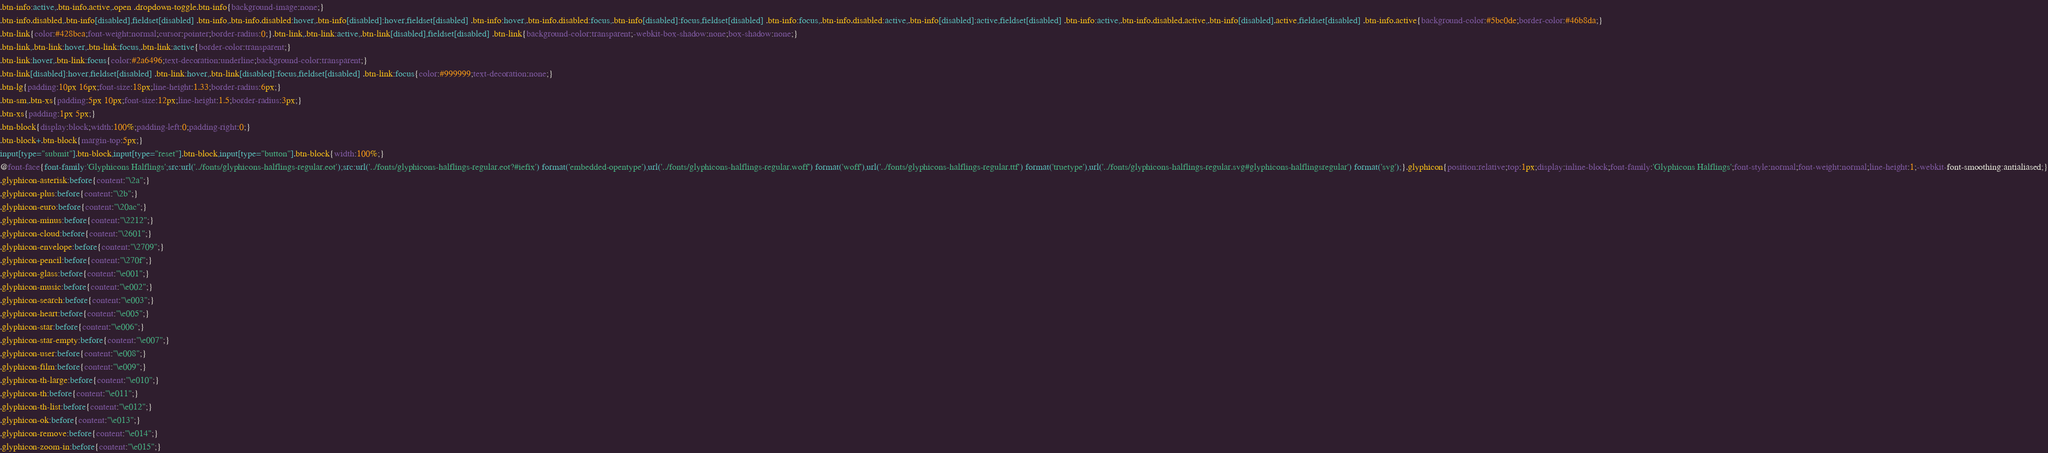Convert code to text. <code><loc_0><loc_0><loc_500><loc_500><_CSS_>.btn-info:active,.btn-info.active,.open .dropdown-toggle.btn-info{background-image:none;}
.btn-info.disabled,.btn-info[disabled],fieldset[disabled] .btn-info,.btn-info.disabled:hover,.btn-info[disabled]:hover,fieldset[disabled] .btn-info:hover,.btn-info.disabled:focus,.btn-info[disabled]:focus,fieldset[disabled] .btn-info:focus,.btn-info.disabled:active,.btn-info[disabled]:active,fieldset[disabled] .btn-info:active,.btn-info.disabled.active,.btn-info[disabled].active,fieldset[disabled] .btn-info.active{background-color:#5bc0de;border-color:#46b8da;}
.btn-link{color:#428bca;font-weight:normal;cursor:pointer;border-radius:0;}.btn-link,.btn-link:active,.btn-link[disabled],fieldset[disabled] .btn-link{background-color:transparent;-webkit-box-shadow:none;box-shadow:none;}
.btn-link,.btn-link:hover,.btn-link:focus,.btn-link:active{border-color:transparent;}
.btn-link:hover,.btn-link:focus{color:#2a6496;text-decoration:underline;background-color:transparent;}
.btn-link[disabled]:hover,fieldset[disabled] .btn-link:hover,.btn-link[disabled]:focus,fieldset[disabled] .btn-link:focus{color:#999999;text-decoration:none;}
.btn-lg{padding:10px 16px;font-size:18px;line-height:1.33;border-radius:6px;}
.btn-sm,.btn-xs{padding:5px 10px;font-size:12px;line-height:1.5;border-radius:3px;}
.btn-xs{padding:1px 5px;}
.btn-block{display:block;width:100%;padding-left:0;padding-right:0;}
.btn-block+.btn-block{margin-top:5px;}
input[type="submit"].btn-block,input[type="reset"].btn-block,input[type="button"].btn-block{width:100%;}
@font-face{font-family:'Glyphicons Halflings';src:url('../fonts/glyphicons-halflings-regular.eot');src:url('../fonts/glyphicons-halflings-regular.eot?#iefix') format('embedded-opentype'),url('../fonts/glyphicons-halflings-regular.woff') format('woff'),url('../fonts/glyphicons-halflings-regular.ttf') format('truetype'),url('../fonts/glyphicons-halflings-regular.svg#glyphicons-halflingsregular') format('svg');}.glyphicon{position:relative;top:1px;display:inline-block;font-family:'Glyphicons Halflings';font-style:normal;font-weight:normal;line-height:1;-webkit-font-smoothing:antialiased;}
.glyphicon-asterisk:before{content:"\2a";}
.glyphicon-plus:before{content:"\2b";}
.glyphicon-euro:before{content:"\20ac";}
.glyphicon-minus:before{content:"\2212";}
.glyphicon-cloud:before{content:"\2601";}
.glyphicon-envelope:before{content:"\2709";}
.glyphicon-pencil:before{content:"\270f";}
.glyphicon-glass:before{content:"\e001";}
.glyphicon-music:before{content:"\e002";}
.glyphicon-search:before{content:"\e003";}
.glyphicon-heart:before{content:"\e005";}
.glyphicon-star:before{content:"\e006";}
.glyphicon-star-empty:before{content:"\e007";}
.glyphicon-user:before{content:"\e008";}
.glyphicon-film:before{content:"\e009";}
.glyphicon-th-large:before{content:"\e010";}
.glyphicon-th:before{content:"\e011";}
.glyphicon-th-list:before{content:"\e012";}
.glyphicon-ok:before{content:"\e013";}
.glyphicon-remove:before{content:"\e014";}
.glyphicon-zoom-in:before{content:"\e015";}</code> 